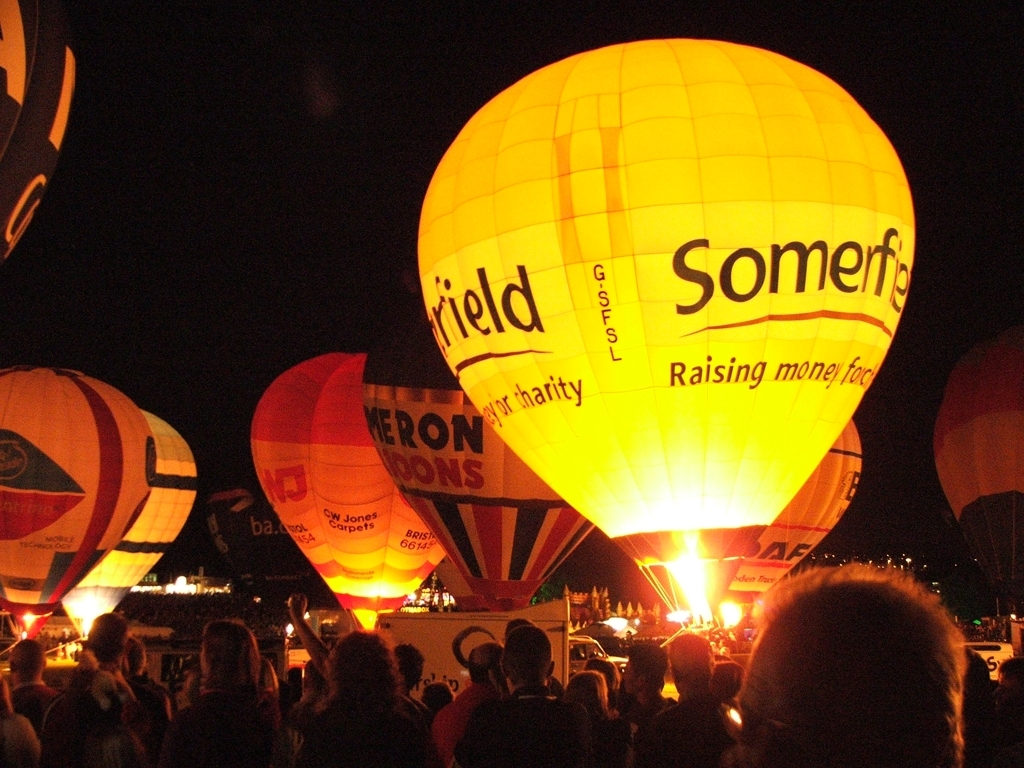Are hot air balloon events like this one safe to attend? Yes, hot air balloon events are generally safe for spectators to attend. These events are often managed with strict safety protocols, ensuring that balloons are securely tethered during illumination displays and that there is safe distance between the balloons and the audience. Regular inspections and experienced pilots contribute to the overall safety of such events. 